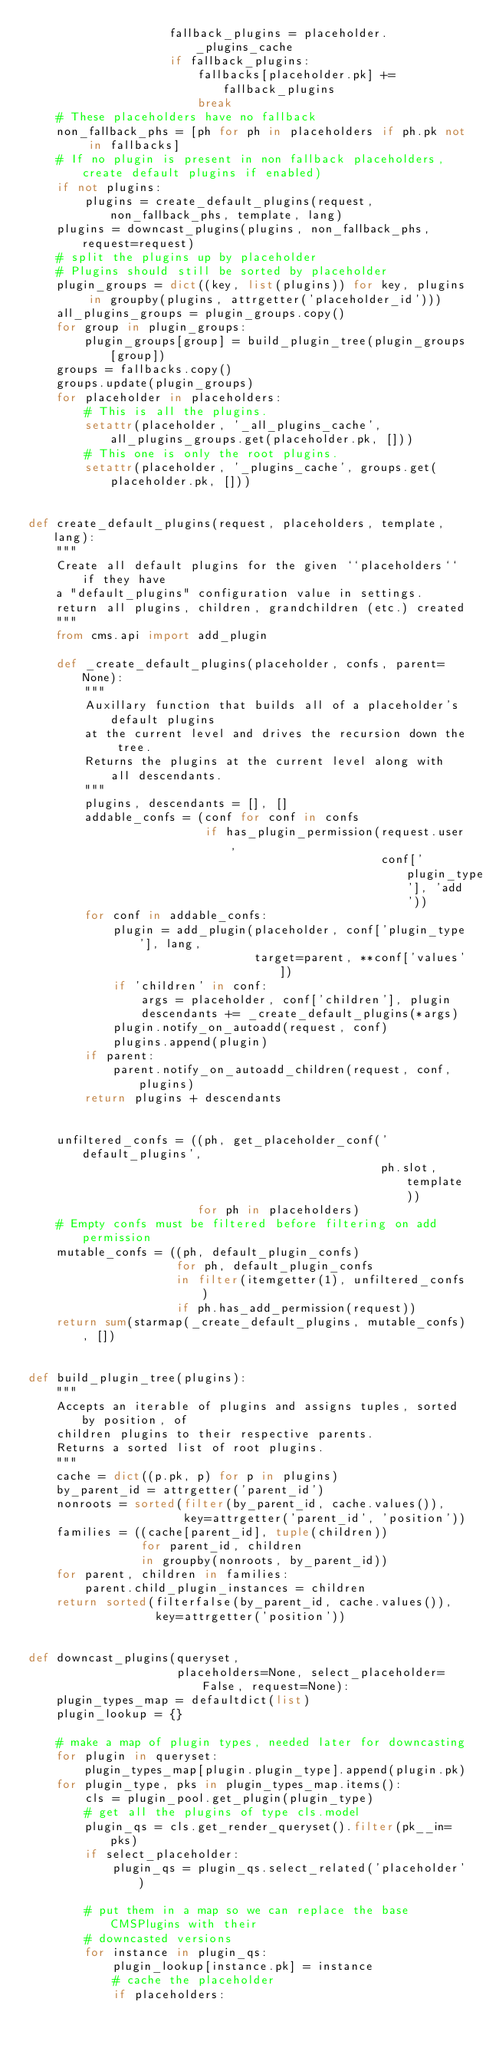<code> <loc_0><loc_0><loc_500><loc_500><_Python_>                    fallback_plugins = placeholder._plugins_cache
                    if fallback_plugins:
                        fallbacks[placeholder.pk] += fallback_plugins
                        break
    # These placeholders have no fallback
    non_fallback_phs = [ph for ph in placeholders if ph.pk not in fallbacks]
    # If no plugin is present in non fallback placeholders, create default plugins if enabled)
    if not plugins:
        plugins = create_default_plugins(request, non_fallback_phs, template, lang)
    plugins = downcast_plugins(plugins, non_fallback_phs, request=request)
    # split the plugins up by placeholder
    # Plugins should still be sorted by placeholder
    plugin_groups = dict((key, list(plugins)) for key, plugins in groupby(plugins, attrgetter('placeholder_id')))
    all_plugins_groups = plugin_groups.copy()
    for group in plugin_groups:
        plugin_groups[group] = build_plugin_tree(plugin_groups[group])
    groups = fallbacks.copy()
    groups.update(plugin_groups)
    for placeholder in placeholders:
        # This is all the plugins.
        setattr(placeholder, '_all_plugins_cache', all_plugins_groups.get(placeholder.pk, []))
        # This one is only the root plugins.
        setattr(placeholder, '_plugins_cache', groups.get(placeholder.pk, []))


def create_default_plugins(request, placeholders, template, lang):
    """
    Create all default plugins for the given ``placeholders`` if they have
    a "default_plugins" configuration value in settings.
    return all plugins, children, grandchildren (etc.) created
    """
    from cms.api import add_plugin

    def _create_default_plugins(placeholder, confs, parent=None):
        """
        Auxillary function that builds all of a placeholder's default plugins
        at the current level and drives the recursion down the tree.
        Returns the plugins at the current level along with all descendants.
        """
        plugins, descendants = [], []
        addable_confs = (conf for conf in confs
                         if has_plugin_permission(request.user,
                                                  conf['plugin_type'], 'add'))
        for conf in addable_confs:
            plugin = add_plugin(placeholder, conf['plugin_type'], lang,
                                target=parent, **conf['values'])
            if 'children' in conf:
                args = placeholder, conf['children'], plugin
                descendants += _create_default_plugins(*args)
            plugin.notify_on_autoadd(request, conf)
            plugins.append(plugin)
        if parent:
            parent.notify_on_autoadd_children(request, conf, plugins)
        return plugins + descendants


    unfiltered_confs = ((ph, get_placeholder_conf('default_plugins',
                                                  ph.slot, template))
                        for ph in placeholders)
    # Empty confs must be filtered before filtering on add permission
    mutable_confs = ((ph, default_plugin_confs)
                     for ph, default_plugin_confs
                     in filter(itemgetter(1), unfiltered_confs)
                     if ph.has_add_permission(request))
    return sum(starmap(_create_default_plugins, mutable_confs), [])


def build_plugin_tree(plugins):
    """
    Accepts an iterable of plugins and assigns tuples, sorted by position, of
    children plugins to their respective parents.
    Returns a sorted list of root plugins.
    """
    cache = dict((p.pk, p) for p in plugins)
    by_parent_id = attrgetter('parent_id')
    nonroots = sorted(filter(by_parent_id, cache.values()),
                      key=attrgetter('parent_id', 'position'))
    families = ((cache[parent_id], tuple(children))
                for parent_id, children
                in groupby(nonroots, by_parent_id))
    for parent, children in families:
        parent.child_plugin_instances = children
    return sorted(filterfalse(by_parent_id, cache.values()),
                  key=attrgetter('position'))


def downcast_plugins(queryset,
                     placeholders=None, select_placeholder=False, request=None):
    plugin_types_map = defaultdict(list)
    plugin_lookup = {}

    # make a map of plugin types, needed later for downcasting
    for plugin in queryset:
        plugin_types_map[plugin.plugin_type].append(plugin.pk)
    for plugin_type, pks in plugin_types_map.items():
        cls = plugin_pool.get_plugin(plugin_type)
        # get all the plugins of type cls.model
        plugin_qs = cls.get_render_queryset().filter(pk__in=pks)
        if select_placeholder:
            plugin_qs = plugin_qs.select_related('placeholder')

        # put them in a map so we can replace the base CMSPlugins with their
        # downcasted versions
        for instance in plugin_qs:
            plugin_lookup[instance.pk] = instance
            # cache the placeholder
            if placeholders:</code> 